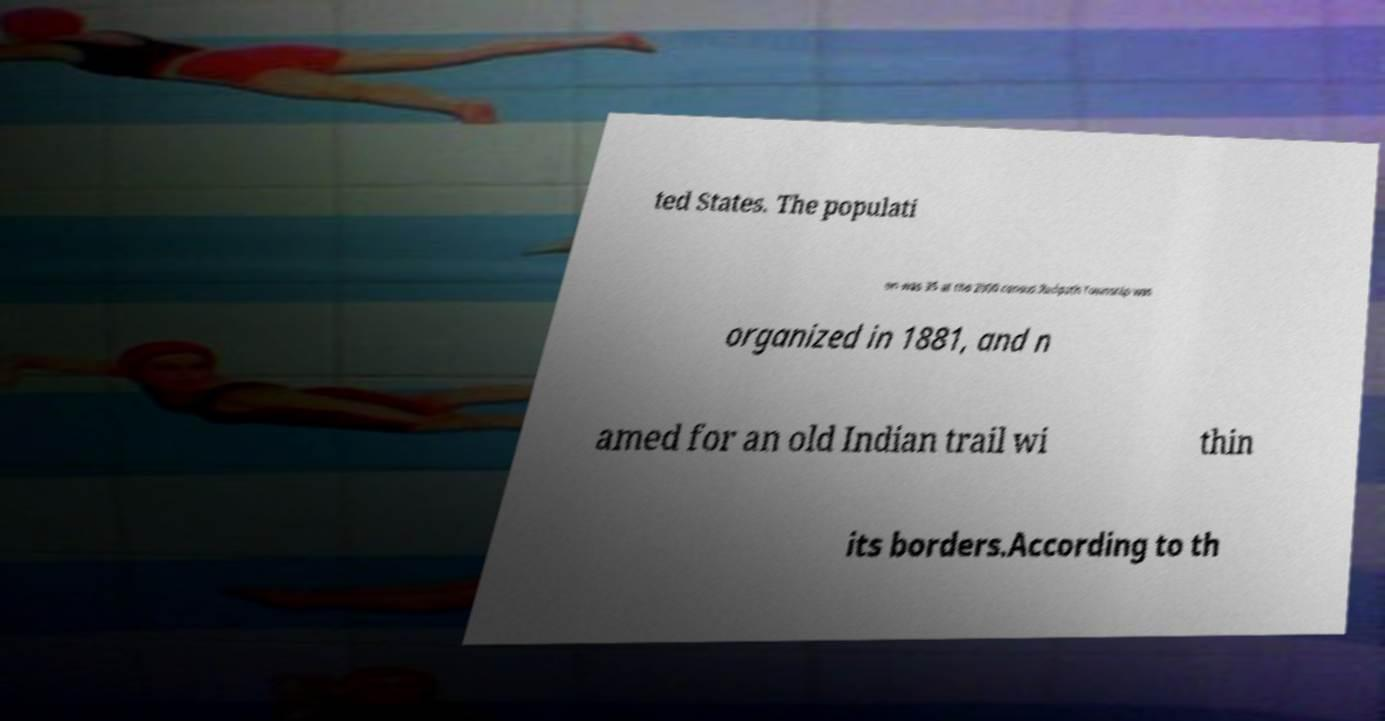Could you assist in decoding the text presented in this image and type it out clearly? ted States. The populati on was 35 at the 2000 census.Redpath Township was organized in 1881, and n amed for an old Indian trail wi thin its borders.According to th 